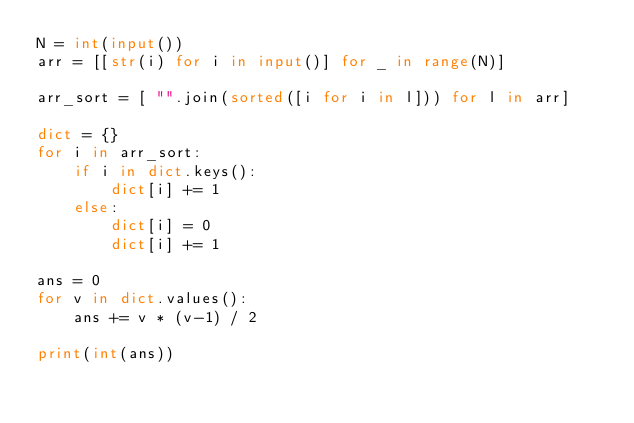Convert code to text. <code><loc_0><loc_0><loc_500><loc_500><_Python_>N = int(input())
arr = [[str(i) for i in input()] for _ in range(N)]

arr_sort = [ "".join(sorted([i for i in l])) for l in arr]

dict = {}
for i in arr_sort:
    if i in dict.keys():
        dict[i] += 1
    else:
        dict[i] = 0
        dict[i] += 1
        
ans = 0
for v in dict.values():
    ans += v * (v-1) / 2
    
print(int(ans))</code> 